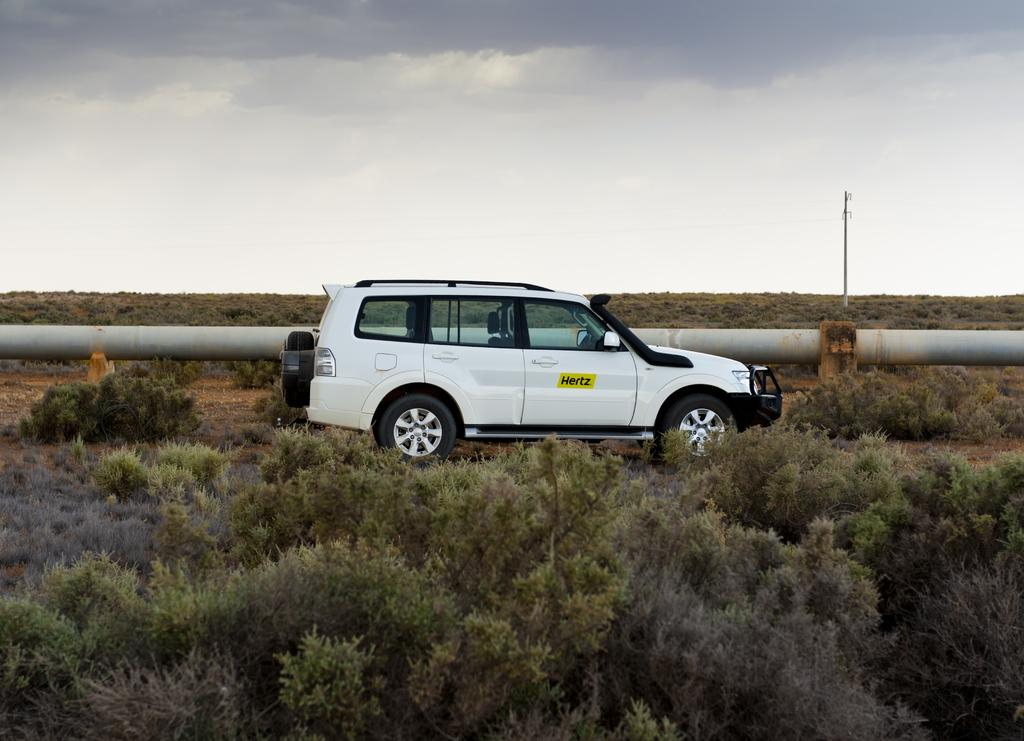What is the main subject of the image? The main subject of the image is a car. What other objects or features can be seen in the image? There are trees and a pipeline visible in the image. What is visible at the top of the image? The sky is visible at the top of the image. What type of linen is used to design the car's interior in the image? There is no information about the car's interior or the use of linen in the image. What kind of jeans can be seen hanging on the trees in the image? There are no jeans present in the image; it only features a car, trees, a pipeline, and the sky. 